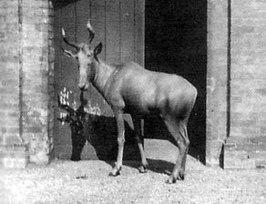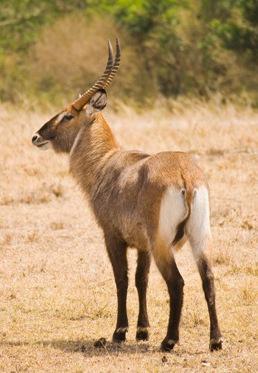The first image is the image on the left, the second image is the image on the right. For the images displayed, is the sentence "there are 3 antelope in the image pair" factually correct? Answer yes or no. No. 